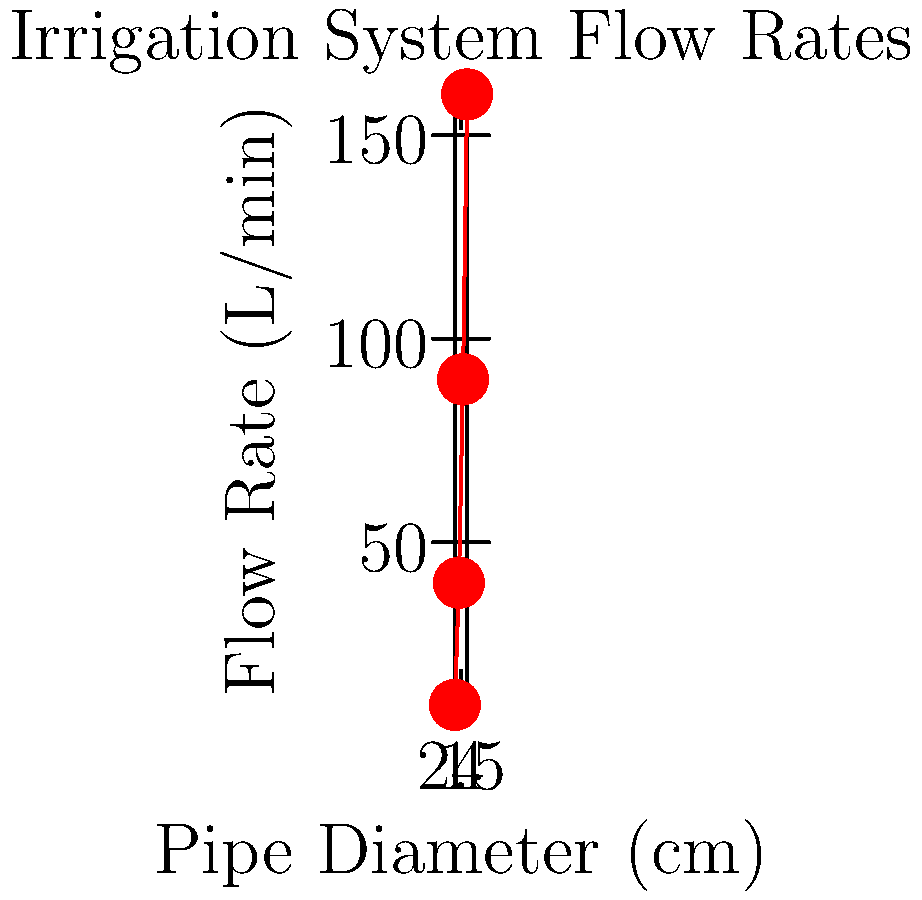You are planning a new irrigation system for your farm. The graph shows the relationship between pipe diameter and water flow rate. If you need a flow rate of at least 75 L/min for your crops, what is the minimum pipe diameter you should use? To find the minimum pipe diameter for a flow rate of at least 75 L/min, we need to analyze the graph:

1. Locate 75 L/min on the y-axis (Flow Rate).
2. Draw a horizontal line from this point to intersect the curve.
3. From the intersection point, draw a vertical line down to the x-axis (Pipe Diameter).

Looking at the graph:
- 1 cm diameter pipe: ~10 L/min (too low)
- 2 cm diameter pipe: ~40 L/min (too low)
- 3 cm diameter pipe: ~90 L/min (sufficient)
- 4 cm diameter pipe: ~160 L/min (more than needed)

The 3 cm diameter pipe is the first to exceed 75 L/min, providing approximately 90 L/min.

Therefore, the minimum pipe diameter needed is 3 cm.
Answer: 3 cm 